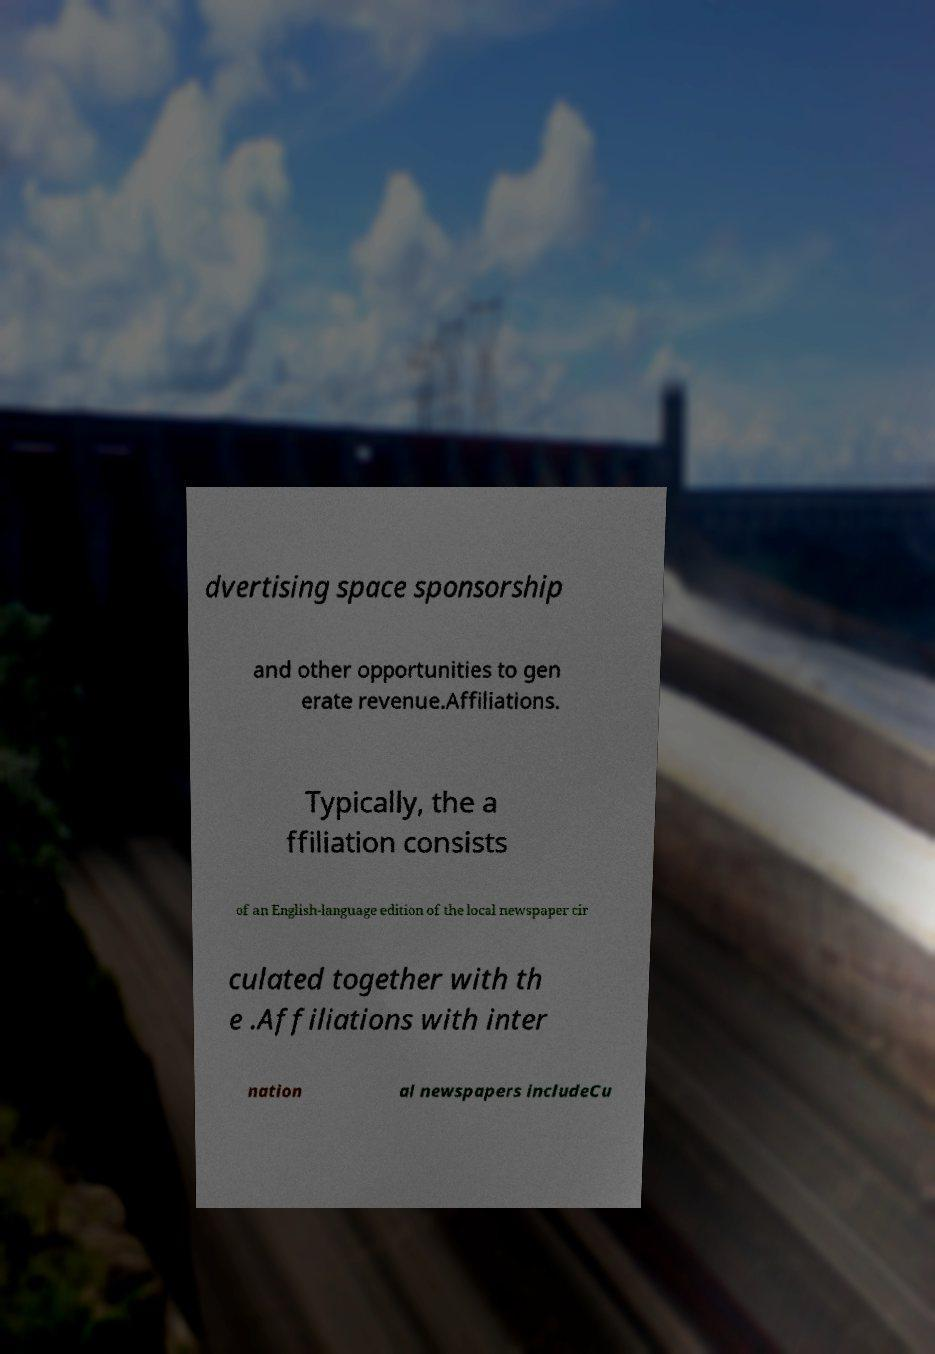For documentation purposes, I need the text within this image transcribed. Could you provide that? dvertising space sponsorship and other opportunities to gen erate revenue.Affiliations. Typically, the a ffiliation consists of an English-language edition of the local newspaper cir culated together with th e .Affiliations with inter nation al newspapers includeCu 